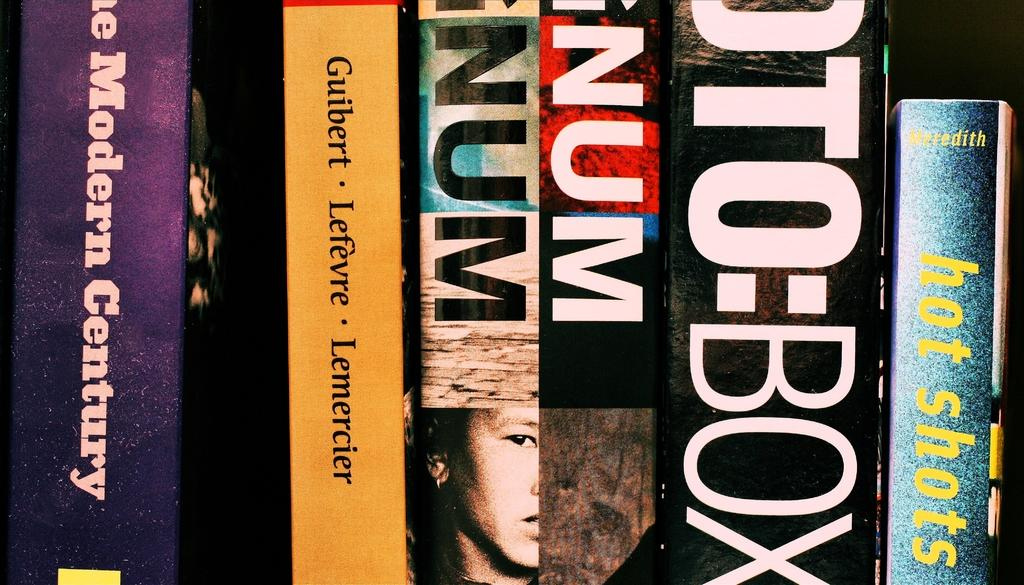<image>
Relay a brief, clear account of the picture shown. A book called Hot Shots has a sparkly blue spine. 